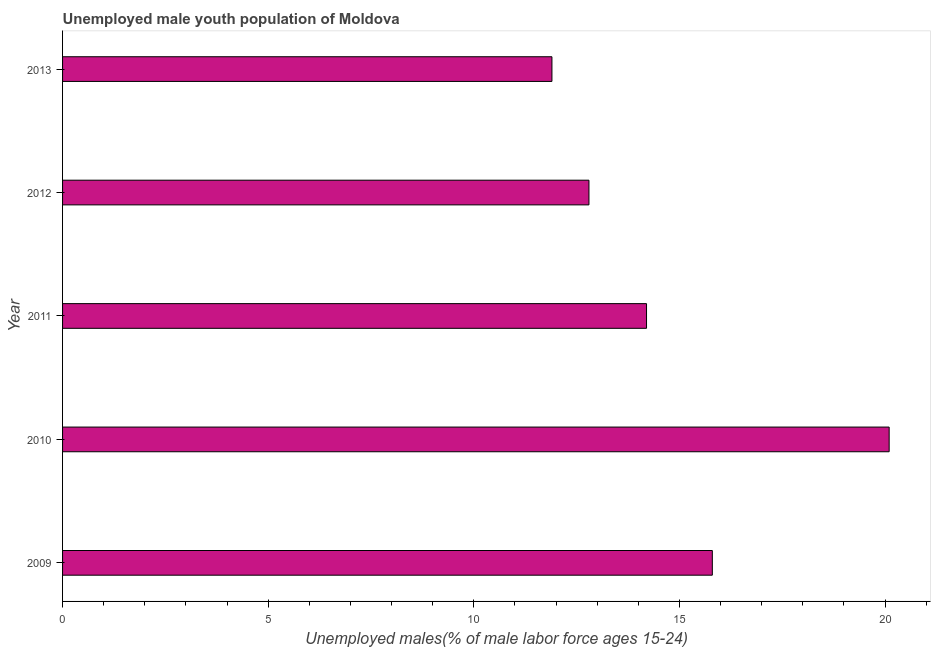Does the graph contain any zero values?
Make the answer very short. No. What is the title of the graph?
Provide a succinct answer. Unemployed male youth population of Moldova. What is the label or title of the X-axis?
Give a very brief answer. Unemployed males(% of male labor force ages 15-24). What is the unemployed male youth in 2011?
Keep it short and to the point. 14.2. Across all years, what is the maximum unemployed male youth?
Make the answer very short. 20.1. Across all years, what is the minimum unemployed male youth?
Ensure brevity in your answer.  11.9. What is the sum of the unemployed male youth?
Offer a very short reply. 74.8. What is the average unemployed male youth per year?
Your answer should be very brief. 14.96. What is the median unemployed male youth?
Provide a short and direct response. 14.2. What is the ratio of the unemployed male youth in 2011 to that in 2013?
Offer a very short reply. 1.19. Is the difference between the unemployed male youth in 2011 and 2013 greater than the difference between any two years?
Your answer should be very brief. No. What is the difference between the highest and the lowest unemployed male youth?
Make the answer very short. 8.2. How many bars are there?
Your response must be concise. 5. Are all the bars in the graph horizontal?
Make the answer very short. Yes. How many years are there in the graph?
Offer a terse response. 5. What is the difference between two consecutive major ticks on the X-axis?
Offer a very short reply. 5. Are the values on the major ticks of X-axis written in scientific E-notation?
Offer a terse response. No. What is the Unemployed males(% of male labor force ages 15-24) in 2009?
Ensure brevity in your answer.  15.8. What is the Unemployed males(% of male labor force ages 15-24) of 2010?
Keep it short and to the point. 20.1. What is the Unemployed males(% of male labor force ages 15-24) of 2011?
Your answer should be very brief. 14.2. What is the Unemployed males(% of male labor force ages 15-24) of 2012?
Give a very brief answer. 12.8. What is the Unemployed males(% of male labor force ages 15-24) of 2013?
Keep it short and to the point. 11.9. What is the difference between the Unemployed males(% of male labor force ages 15-24) in 2009 and 2010?
Provide a succinct answer. -4.3. What is the difference between the Unemployed males(% of male labor force ages 15-24) in 2009 and 2012?
Ensure brevity in your answer.  3. What is the difference between the Unemployed males(% of male labor force ages 15-24) in 2010 and 2011?
Provide a succinct answer. 5.9. What is the difference between the Unemployed males(% of male labor force ages 15-24) in 2010 and 2012?
Provide a short and direct response. 7.3. What is the difference between the Unemployed males(% of male labor force ages 15-24) in 2011 and 2012?
Your answer should be very brief. 1.4. What is the ratio of the Unemployed males(% of male labor force ages 15-24) in 2009 to that in 2010?
Your response must be concise. 0.79. What is the ratio of the Unemployed males(% of male labor force ages 15-24) in 2009 to that in 2011?
Ensure brevity in your answer.  1.11. What is the ratio of the Unemployed males(% of male labor force ages 15-24) in 2009 to that in 2012?
Provide a short and direct response. 1.23. What is the ratio of the Unemployed males(% of male labor force ages 15-24) in 2009 to that in 2013?
Offer a very short reply. 1.33. What is the ratio of the Unemployed males(% of male labor force ages 15-24) in 2010 to that in 2011?
Provide a short and direct response. 1.42. What is the ratio of the Unemployed males(% of male labor force ages 15-24) in 2010 to that in 2012?
Ensure brevity in your answer.  1.57. What is the ratio of the Unemployed males(% of male labor force ages 15-24) in 2010 to that in 2013?
Provide a short and direct response. 1.69. What is the ratio of the Unemployed males(% of male labor force ages 15-24) in 2011 to that in 2012?
Your response must be concise. 1.11. What is the ratio of the Unemployed males(% of male labor force ages 15-24) in 2011 to that in 2013?
Ensure brevity in your answer.  1.19. What is the ratio of the Unemployed males(% of male labor force ages 15-24) in 2012 to that in 2013?
Make the answer very short. 1.08. 